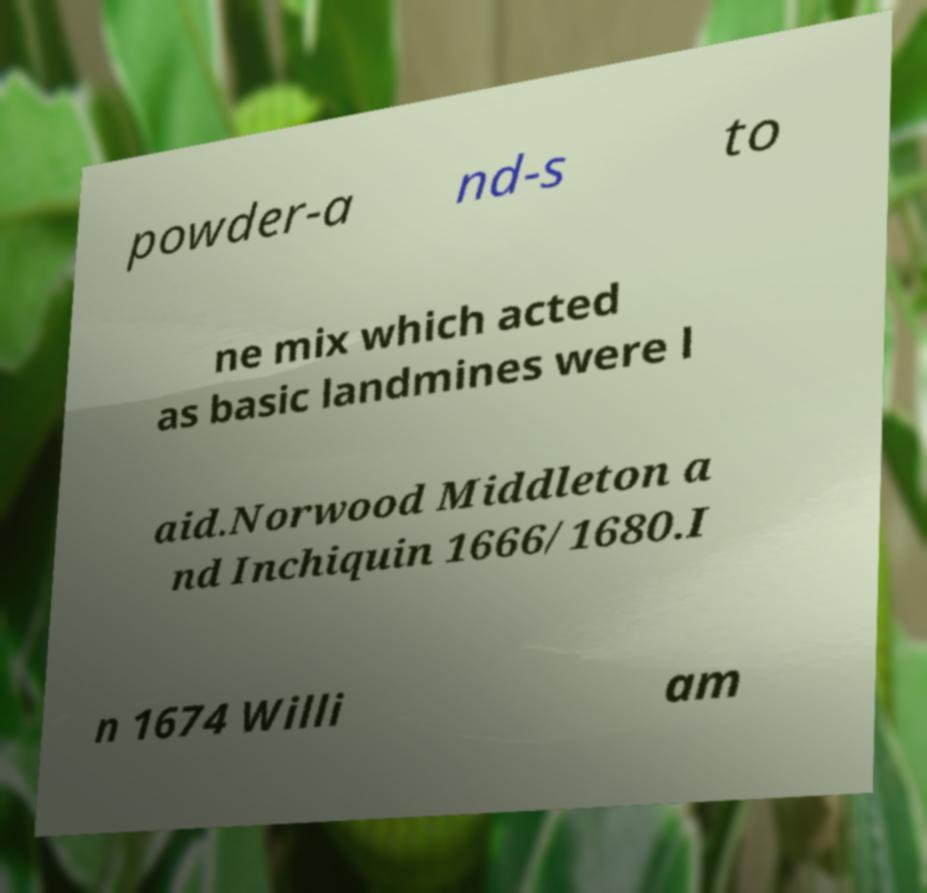Can you accurately transcribe the text from the provided image for me? powder-a nd-s to ne mix which acted as basic landmines were l aid.Norwood Middleton a nd Inchiquin 1666/1680.I n 1674 Willi am 